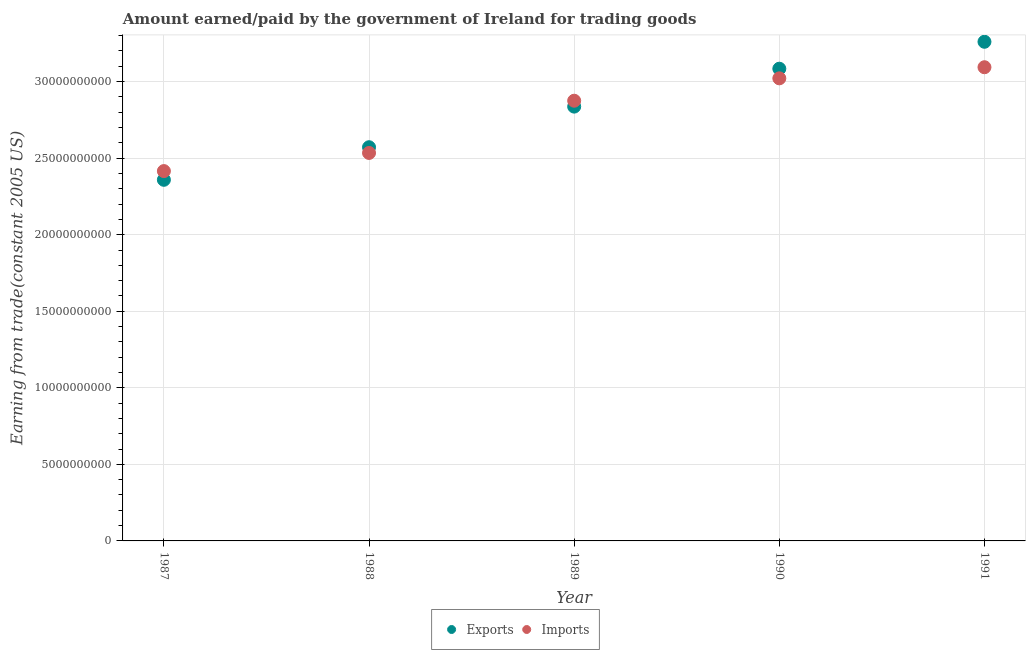Is the number of dotlines equal to the number of legend labels?
Your answer should be compact. Yes. What is the amount earned from exports in 1991?
Offer a terse response. 3.26e+1. Across all years, what is the maximum amount paid for imports?
Your response must be concise. 3.09e+1. Across all years, what is the minimum amount paid for imports?
Ensure brevity in your answer.  2.42e+1. In which year was the amount earned from exports minimum?
Ensure brevity in your answer.  1987. What is the total amount paid for imports in the graph?
Make the answer very short. 1.39e+11. What is the difference between the amount paid for imports in 1989 and that in 1991?
Give a very brief answer. -2.19e+09. What is the difference between the amount earned from exports in 1989 and the amount paid for imports in 1987?
Offer a very short reply. 4.21e+09. What is the average amount paid for imports per year?
Your answer should be compact. 2.79e+1. In the year 1990, what is the difference between the amount earned from exports and amount paid for imports?
Provide a short and direct response. 6.29e+08. In how many years, is the amount paid for imports greater than 32000000000 US$?
Provide a succinct answer. 0. What is the ratio of the amount earned from exports in 1987 to that in 1988?
Ensure brevity in your answer.  0.92. Is the amount earned from exports in 1990 less than that in 1991?
Offer a very short reply. Yes. What is the difference between the highest and the second highest amount paid for imports?
Your answer should be very brief. 7.25e+08. What is the difference between the highest and the lowest amount earned from exports?
Your answer should be very brief. 9.01e+09. Is the sum of the amount paid for imports in 1989 and 1990 greater than the maximum amount earned from exports across all years?
Provide a short and direct response. Yes. Is the amount earned from exports strictly greater than the amount paid for imports over the years?
Provide a succinct answer. No. Are the values on the major ticks of Y-axis written in scientific E-notation?
Keep it short and to the point. No. Does the graph contain any zero values?
Your answer should be very brief. No. Does the graph contain grids?
Offer a very short reply. Yes. How are the legend labels stacked?
Give a very brief answer. Horizontal. What is the title of the graph?
Keep it short and to the point. Amount earned/paid by the government of Ireland for trading goods. What is the label or title of the X-axis?
Provide a succinct answer. Year. What is the label or title of the Y-axis?
Ensure brevity in your answer.  Earning from trade(constant 2005 US). What is the Earning from trade(constant 2005 US) in Exports in 1987?
Ensure brevity in your answer.  2.36e+1. What is the Earning from trade(constant 2005 US) in Imports in 1987?
Your answer should be compact. 2.42e+1. What is the Earning from trade(constant 2005 US) in Exports in 1988?
Provide a short and direct response. 2.57e+1. What is the Earning from trade(constant 2005 US) in Imports in 1988?
Provide a short and direct response. 2.53e+1. What is the Earning from trade(constant 2005 US) in Exports in 1989?
Give a very brief answer. 2.84e+1. What is the Earning from trade(constant 2005 US) of Imports in 1989?
Give a very brief answer. 2.87e+1. What is the Earning from trade(constant 2005 US) in Exports in 1990?
Ensure brevity in your answer.  3.08e+1. What is the Earning from trade(constant 2005 US) in Imports in 1990?
Offer a terse response. 3.02e+1. What is the Earning from trade(constant 2005 US) of Exports in 1991?
Your response must be concise. 3.26e+1. What is the Earning from trade(constant 2005 US) in Imports in 1991?
Provide a succinct answer. 3.09e+1. Across all years, what is the maximum Earning from trade(constant 2005 US) in Exports?
Provide a short and direct response. 3.26e+1. Across all years, what is the maximum Earning from trade(constant 2005 US) of Imports?
Offer a terse response. 3.09e+1. Across all years, what is the minimum Earning from trade(constant 2005 US) of Exports?
Your response must be concise. 2.36e+1. Across all years, what is the minimum Earning from trade(constant 2005 US) of Imports?
Give a very brief answer. 2.42e+1. What is the total Earning from trade(constant 2005 US) of Exports in the graph?
Ensure brevity in your answer.  1.41e+11. What is the total Earning from trade(constant 2005 US) in Imports in the graph?
Your answer should be very brief. 1.39e+11. What is the difference between the Earning from trade(constant 2005 US) of Exports in 1987 and that in 1988?
Keep it short and to the point. -2.13e+09. What is the difference between the Earning from trade(constant 2005 US) in Imports in 1987 and that in 1988?
Your answer should be compact. -1.18e+09. What is the difference between the Earning from trade(constant 2005 US) in Exports in 1987 and that in 1989?
Your answer should be very brief. -4.78e+09. What is the difference between the Earning from trade(constant 2005 US) in Imports in 1987 and that in 1989?
Offer a terse response. -4.60e+09. What is the difference between the Earning from trade(constant 2005 US) in Exports in 1987 and that in 1990?
Make the answer very short. -7.26e+09. What is the difference between the Earning from trade(constant 2005 US) in Imports in 1987 and that in 1990?
Keep it short and to the point. -6.06e+09. What is the difference between the Earning from trade(constant 2005 US) in Exports in 1987 and that in 1991?
Your answer should be compact. -9.01e+09. What is the difference between the Earning from trade(constant 2005 US) of Imports in 1987 and that in 1991?
Provide a short and direct response. -6.78e+09. What is the difference between the Earning from trade(constant 2005 US) of Exports in 1988 and that in 1989?
Provide a short and direct response. -2.65e+09. What is the difference between the Earning from trade(constant 2005 US) in Imports in 1988 and that in 1989?
Keep it short and to the point. -3.41e+09. What is the difference between the Earning from trade(constant 2005 US) in Exports in 1988 and that in 1990?
Provide a short and direct response. -5.13e+09. What is the difference between the Earning from trade(constant 2005 US) of Imports in 1988 and that in 1990?
Give a very brief answer. -4.87e+09. What is the difference between the Earning from trade(constant 2005 US) in Exports in 1988 and that in 1991?
Keep it short and to the point. -6.89e+09. What is the difference between the Earning from trade(constant 2005 US) in Imports in 1988 and that in 1991?
Give a very brief answer. -5.60e+09. What is the difference between the Earning from trade(constant 2005 US) in Exports in 1989 and that in 1990?
Keep it short and to the point. -2.48e+09. What is the difference between the Earning from trade(constant 2005 US) in Imports in 1989 and that in 1990?
Provide a short and direct response. -1.46e+09. What is the difference between the Earning from trade(constant 2005 US) in Exports in 1989 and that in 1991?
Give a very brief answer. -4.23e+09. What is the difference between the Earning from trade(constant 2005 US) of Imports in 1989 and that in 1991?
Offer a terse response. -2.19e+09. What is the difference between the Earning from trade(constant 2005 US) of Exports in 1990 and that in 1991?
Provide a short and direct response. -1.76e+09. What is the difference between the Earning from trade(constant 2005 US) of Imports in 1990 and that in 1991?
Make the answer very short. -7.25e+08. What is the difference between the Earning from trade(constant 2005 US) of Exports in 1987 and the Earning from trade(constant 2005 US) of Imports in 1988?
Your answer should be compact. -1.75e+09. What is the difference between the Earning from trade(constant 2005 US) of Exports in 1987 and the Earning from trade(constant 2005 US) of Imports in 1989?
Offer a very short reply. -5.17e+09. What is the difference between the Earning from trade(constant 2005 US) of Exports in 1987 and the Earning from trade(constant 2005 US) of Imports in 1990?
Ensure brevity in your answer.  -6.63e+09. What is the difference between the Earning from trade(constant 2005 US) in Exports in 1987 and the Earning from trade(constant 2005 US) in Imports in 1991?
Offer a very short reply. -7.35e+09. What is the difference between the Earning from trade(constant 2005 US) in Exports in 1988 and the Earning from trade(constant 2005 US) in Imports in 1989?
Your answer should be very brief. -3.04e+09. What is the difference between the Earning from trade(constant 2005 US) of Exports in 1988 and the Earning from trade(constant 2005 US) of Imports in 1990?
Your response must be concise. -4.50e+09. What is the difference between the Earning from trade(constant 2005 US) in Exports in 1988 and the Earning from trade(constant 2005 US) in Imports in 1991?
Provide a short and direct response. -5.22e+09. What is the difference between the Earning from trade(constant 2005 US) of Exports in 1989 and the Earning from trade(constant 2005 US) of Imports in 1990?
Give a very brief answer. -1.85e+09. What is the difference between the Earning from trade(constant 2005 US) of Exports in 1989 and the Earning from trade(constant 2005 US) of Imports in 1991?
Ensure brevity in your answer.  -2.57e+09. What is the difference between the Earning from trade(constant 2005 US) in Exports in 1990 and the Earning from trade(constant 2005 US) in Imports in 1991?
Provide a succinct answer. -9.63e+07. What is the average Earning from trade(constant 2005 US) of Exports per year?
Make the answer very short. 2.82e+1. What is the average Earning from trade(constant 2005 US) of Imports per year?
Offer a very short reply. 2.79e+1. In the year 1987, what is the difference between the Earning from trade(constant 2005 US) of Exports and Earning from trade(constant 2005 US) of Imports?
Provide a succinct answer. -5.70e+08. In the year 1988, what is the difference between the Earning from trade(constant 2005 US) in Exports and Earning from trade(constant 2005 US) in Imports?
Your response must be concise. 3.74e+08. In the year 1989, what is the difference between the Earning from trade(constant 2005 US) in Exports and Earning from trade(constant 2005 US) in Imports?
Your answer should be compact. -3.85e+08. In the year 1990, what is the difference between the Earning from trade(constant 2005 US) of Exports and Earning from trade(constant 2005 US) of Imports?
Ensure brevity in your answer.  6.29e+08. In the year 1991, what is the difference between the Earning from trade(constant 2005 US) in Exports and Earning from trade(constant 2005 US) in Imports?
Offer a very short reply. 1.66e+09. What is the ratio of the Earning from trade(constant 2005 US) of Exports in 1987 to that in 1988?
Ensure brevity in your answer.  0.92. What is the ratio of the Earning from trade(constant 2005 US) of Imports in 1987 to that in 1988?
Offer a very short reply. 0.95. What is the ratio of the Earning from trade(constant 2005 US) in Exports in 1987 to that in 1989?
Give a very brief answer. 0.83. What is the ratio of the Earning from trade(constant 2005 US) of Imports in 1987 to that in 1989?
Make the answer very short. 0.84. What is the ratio of the Earning from trade(constant 2005 US) of Exports in 1987 to that in 1990?
Give a very brief answer. 0.76. What is the ratio of the Earning from trade(constant 2005 US) of Imports in 1987 to that in 1990?
Provide a succinct answer. 0.8. What is the ratio of the Earning from trade(constant 2005 US) in Exports in 1987 to that in 1991?
Your answer should be very brief. 0.72. What is the ratio of the Earning from trade(constant 2005 US) of Imports in 1987 to that in 1991?
Provide a succinct answer. 0.78. What is the ratio of the Earning from trade(constant 2005 US) of Exports in 1988 to that in 1989?
Provide a short and direct response. 0.91. What is the ratio of the Earning from trade(constant 2005 US) in Imports in 1988 to that in 1989?
Your response must be concise. 0.88. What is the ratio of the Earning from trade(constant 2005 US) in Exports in 1988 to that in 1990?
Offer a terse response. 0.83. What is the ratio of the Earning from trade(constant 2005 US) of Imports in 1988 to that in 1990?
Offer a terse response. 0.84. What is the ratio of the Earning from trade(constant 2005 US) in Exports in 1988 to that in 1991?
Provide a succinct answer. 0.79. What is the ratio of the Earning from trade(constant 2005 US) of Imports in 1988 to that in 1991?
Offer a terse response. 0.82. What is the ratio of the Earning from trade(constant 2005 US) in Exports in 1989 to that in 1990?
Provide a succinct answer. 0.92. What is the ratio of the Earning from trade(constant 2005 US) of Imports in 1989 to that in 1990?
Give a very brief answer. 0.95. What is the ratio of the Earning from trade(constant 2005 US) in Exports in 1989 to that in 1991?
Provide a short and direct response. 0.87. What is the ratio of the Earning from trade(constant 2005 US) of Imports in 1989 to that in 1991?
Your response must be concise. 0.93. What is the ratio of the Earning from trade(constant 2005 US) of Exports in 1990 to that in 1991?
Your answer should be compact. 0.95. What is the ratio of the Earning from trade(constant 2005 US) of Imports in 1990 to that in 1991?
Your response must be concise. 0.98. What is the difference between the highest and the second highest Earning from trade(constant 2005 US) of Exports?
Keep it short and to the point. 1.76e+09. What is the difference between the highest and the second highest Earning from trade(constant 2005 US) in Imports?
Provide a short and direct response. 7.25e+08. What is the difference between the highest and the lowest Earning from trade(constant 2005 US) in Exports?
Your answer should be very brief. 9.01e+09. What is the difference between the highest and the lowest Earning from trade(constant 2005 US) in Imports?
Ensure brevity in your answer.  6.78e+09. 